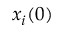Convert formula to latex. <formula><loc_0><loc_0><loc_500><loc_500>x _ { i } ( 0 )</formula> 